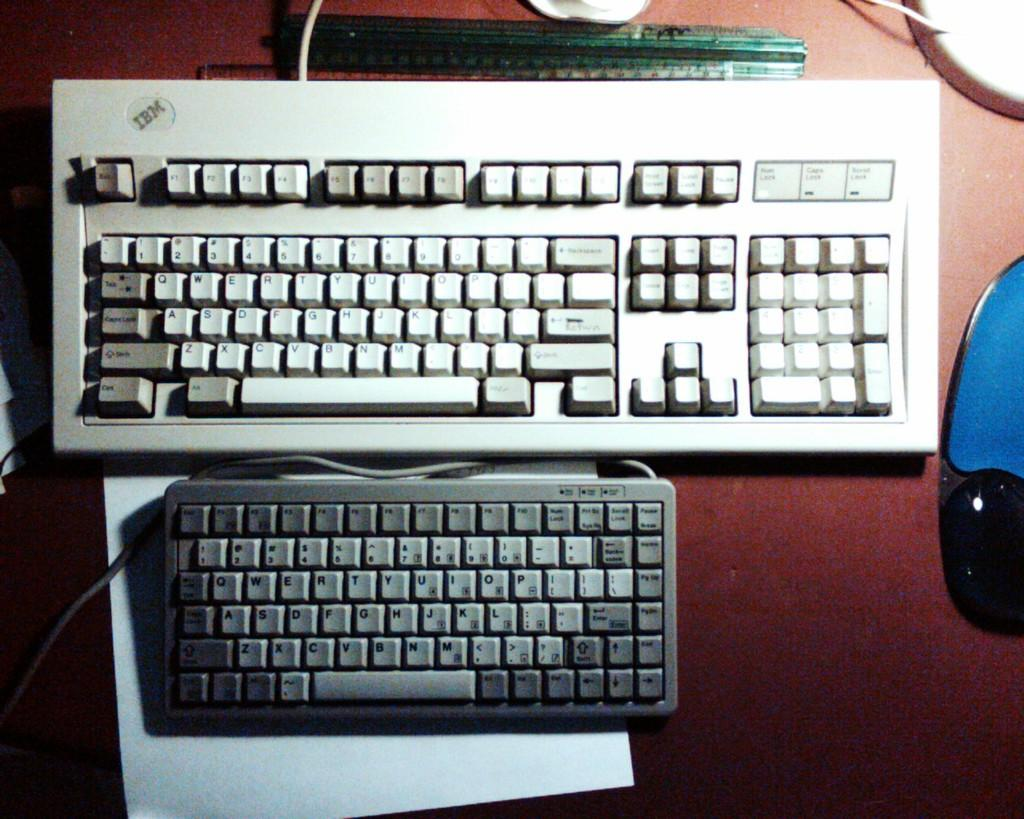What piece of furniture is present in the image? There is a table in the image. What electronic devices are on the table? There are keyboards, a keypad, and a scale on the table. What type of items can be seen on the table besides the electronic devices? There are papers and cables on the table. What type of sofa is visible in the image? There is no sofa present in the image. What is the aftermath of the burn in the image? There is no burn or any related aftermath present in the image. 